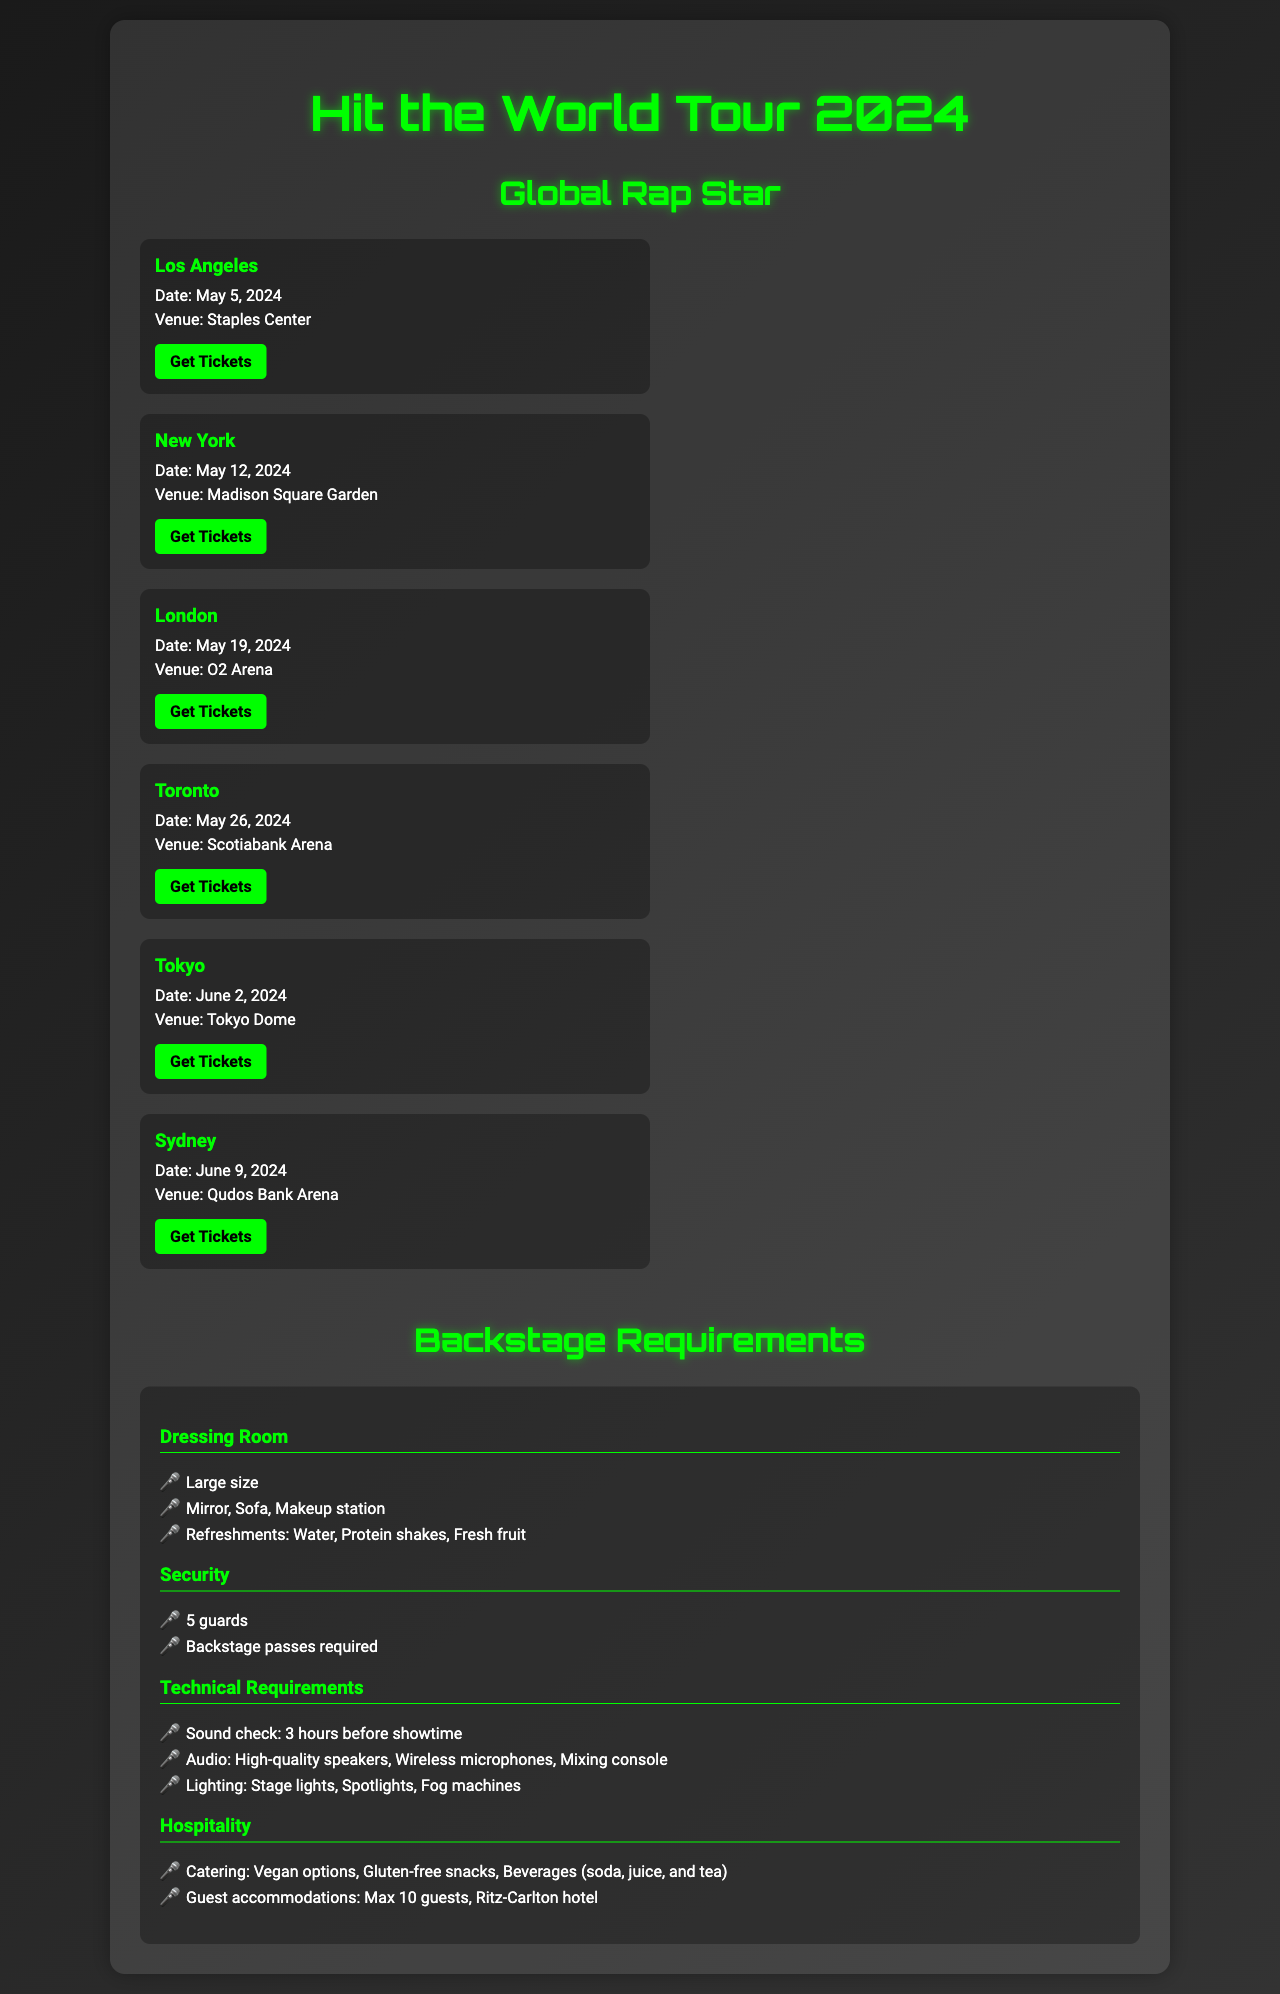What date is the concert in Los Angeles? The concert date can be found under the Los Angeles tour date section, which specifies May 5, 2024.
Answer: May 5, 2024 What venue will the concert in London be held at? The venue for the London concert is mentioned in the London tour date section, which lists O2 Arena.
Answer: O2 Arena How many guests can be accommodated for hospitality? The hospitality section outlines guest accommodations, stating a maximum of 10 guests.
Answer: 10 guests What is required for security during the tour? The security section indicates that 5 guards are needed and backstage passes are required for access.
Answer: 5 guards What beverages are included in the catering options? The hospitality section specifies drink options like soda, juice, and tea.
Answer: Soda, juice, and tea Which city has the concert on June 9, 2024? The tour date section lists Sydney as the city for the concert scheduled on June 9, 2024.
Answer: Sydney How long before showtime is the sound check scheduled? The technical requirements state that the sound check is set for 3 hours before the show begins.
Answer: 3 hours What are the refreshment options listed in the dressing room requirements? The dressing room section mentions refreshments such as water, protein shakes, and fresh fruit.
Answer: Water, protein shakes, fresh fruit 